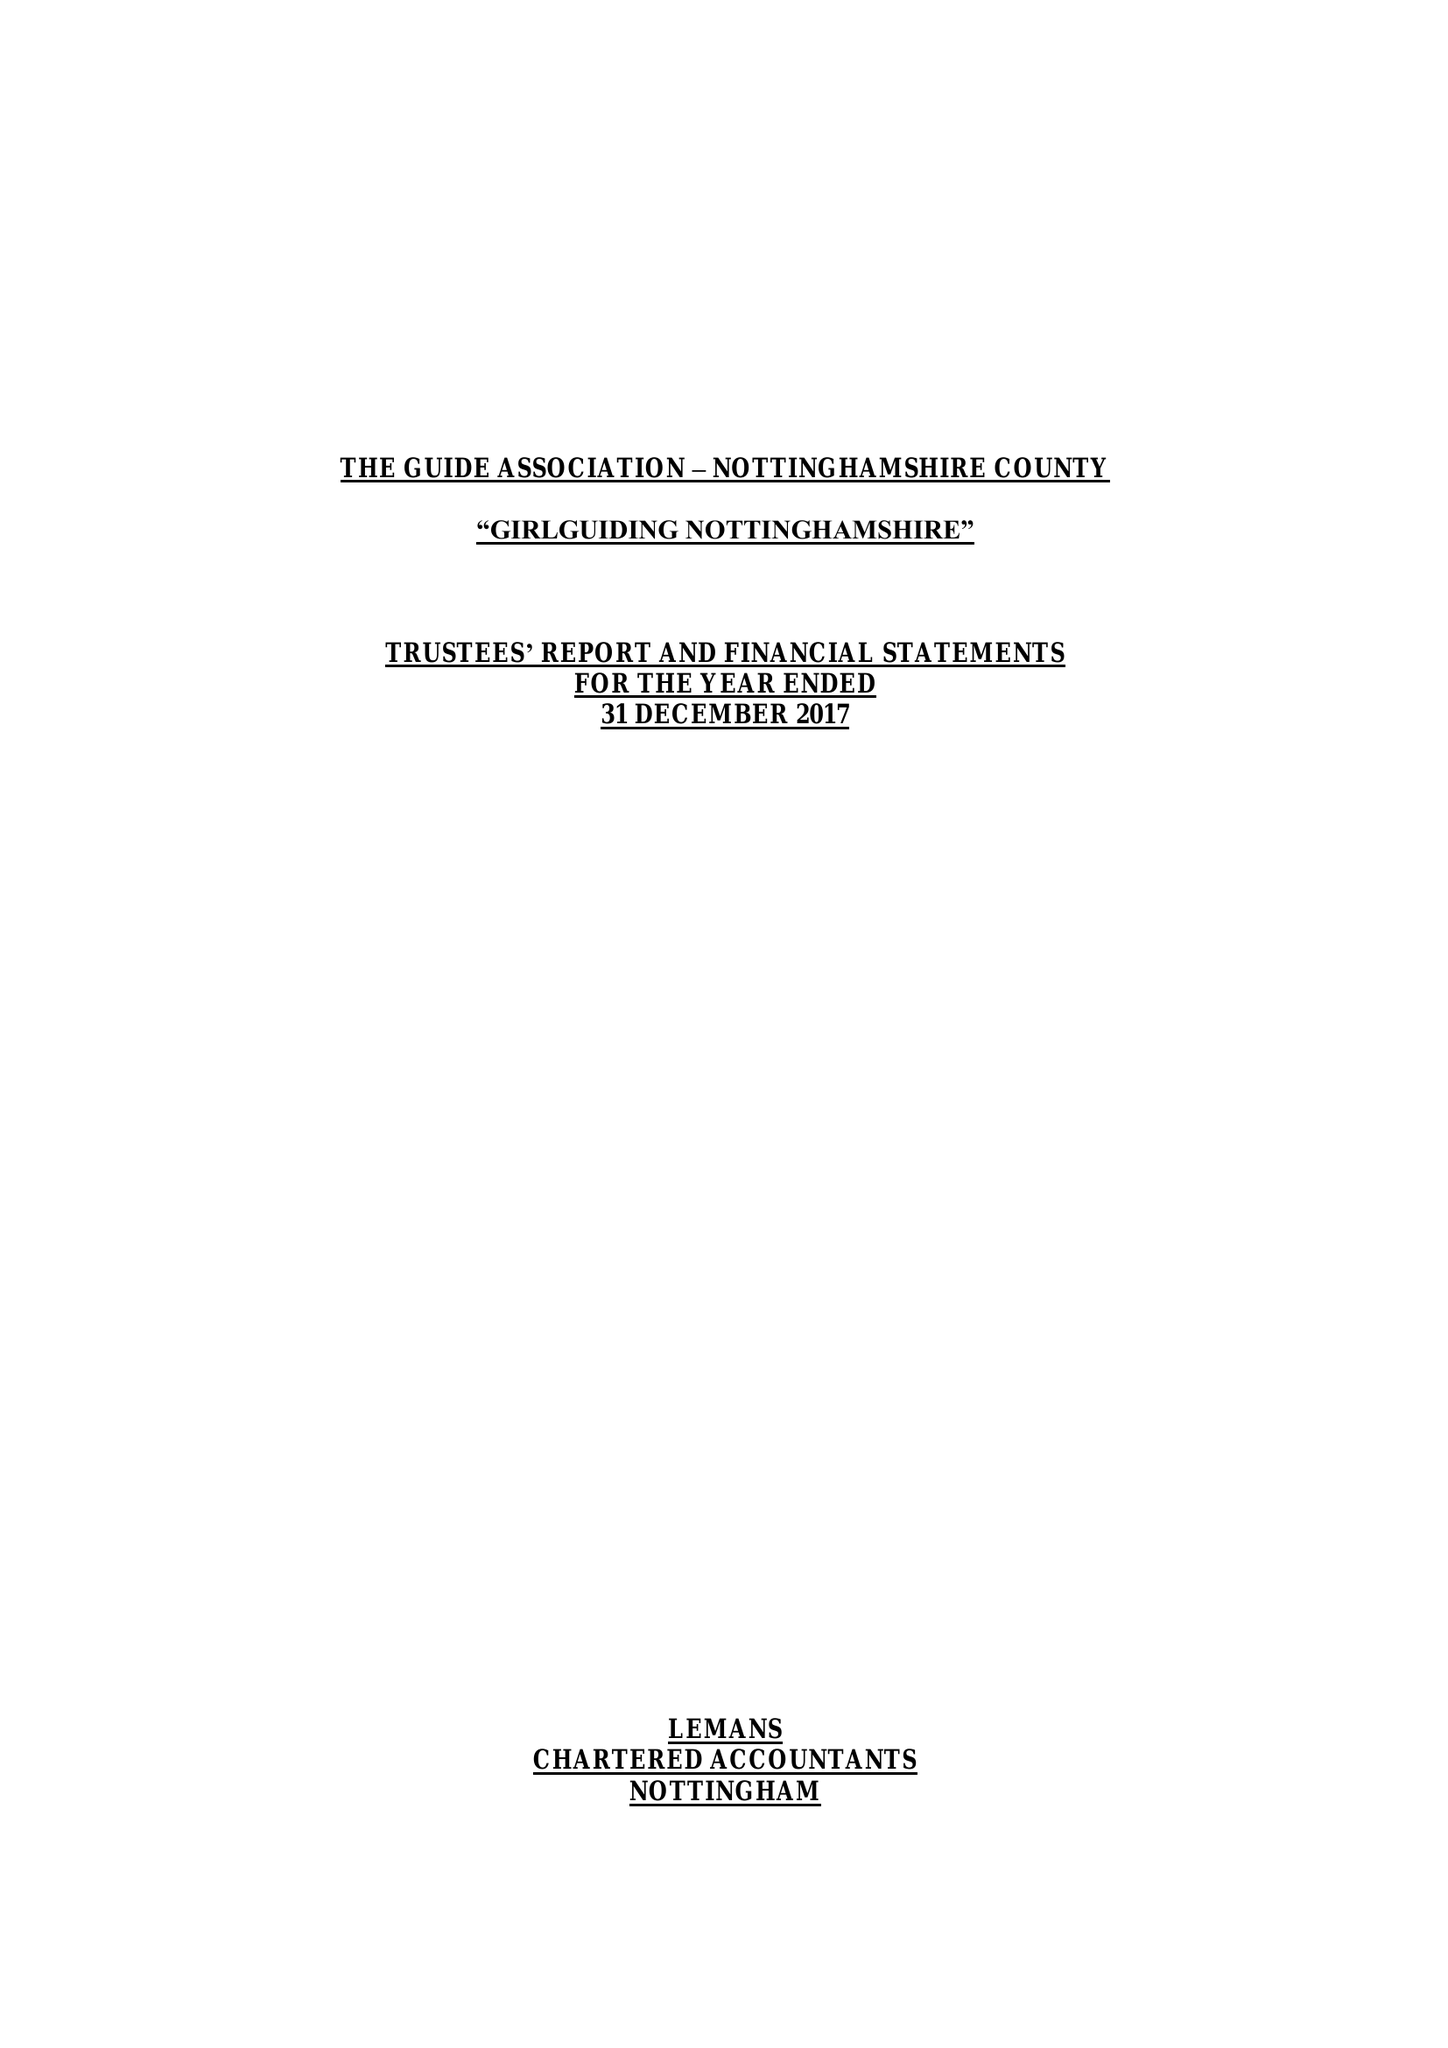What is the value for the report_date?
Answer the question using a single word or phrase. 2017-12-31 